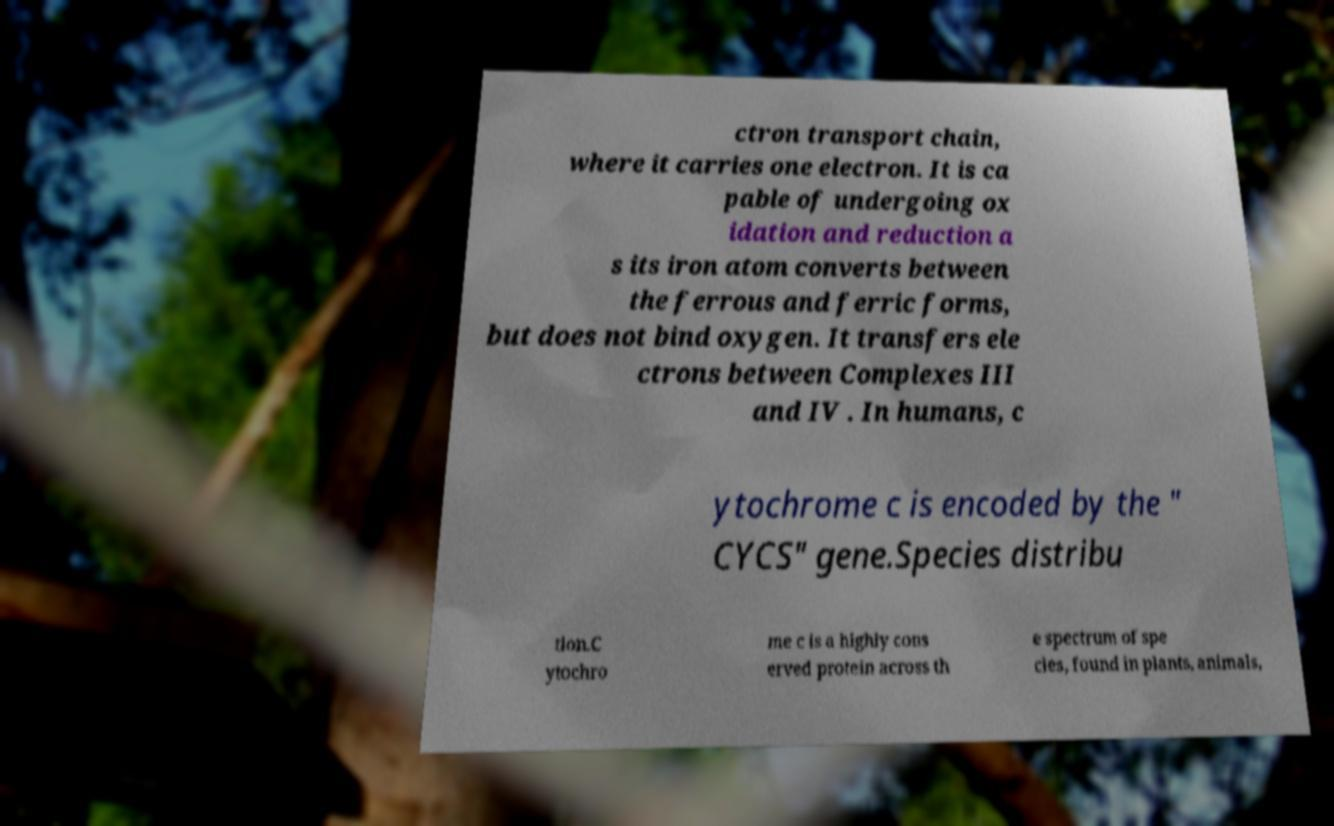Could you assist in decoding the text presented in this image and type it out clearly? ctron transport chain, where it carries one electron. It is ca pable of undergoing ox idation and reduction a s its iron atom converts between the ferrous and ferric forms, but does not bind oxygen. It transfers ele ctrons between Complexes III and IV . In humans, c ytochrome c is encoded by the " CYCS" gene.Species distribu tion.C ytochro me c is a highly cons erved protein across th e spectrum of spe cies, found in plants, animals, 